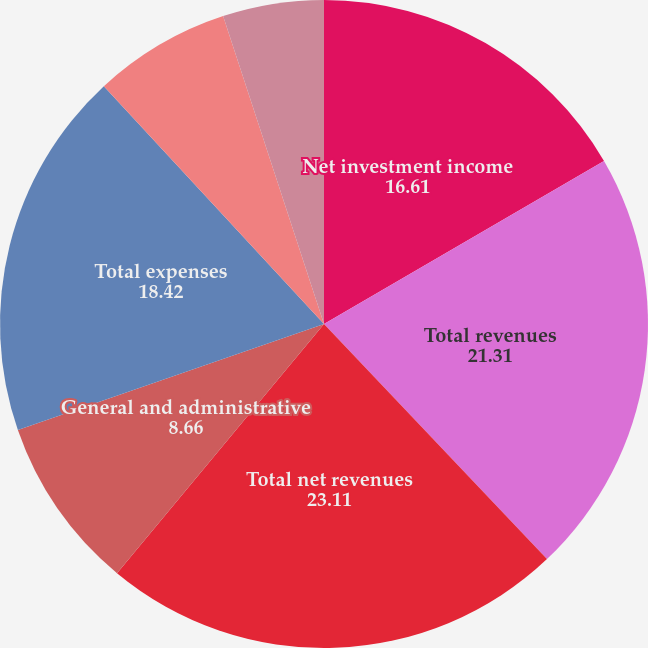<chart> <loc_0><loc_0><loc_500><loc_500><pie_chart><fcel>Net investment income<fcel>Total revenues<fcel>Total net revenues<fcel>General and administrative<fcel>Total expenses<fcel>Income from continuing<fcel>Net income<nl><fcel>16.61%<fcel>21.31%<fcel>23.11%<fcel>8.66%<fcel>18.42%<fcel>6.85%<fcel>5.04%<nl></chart> 